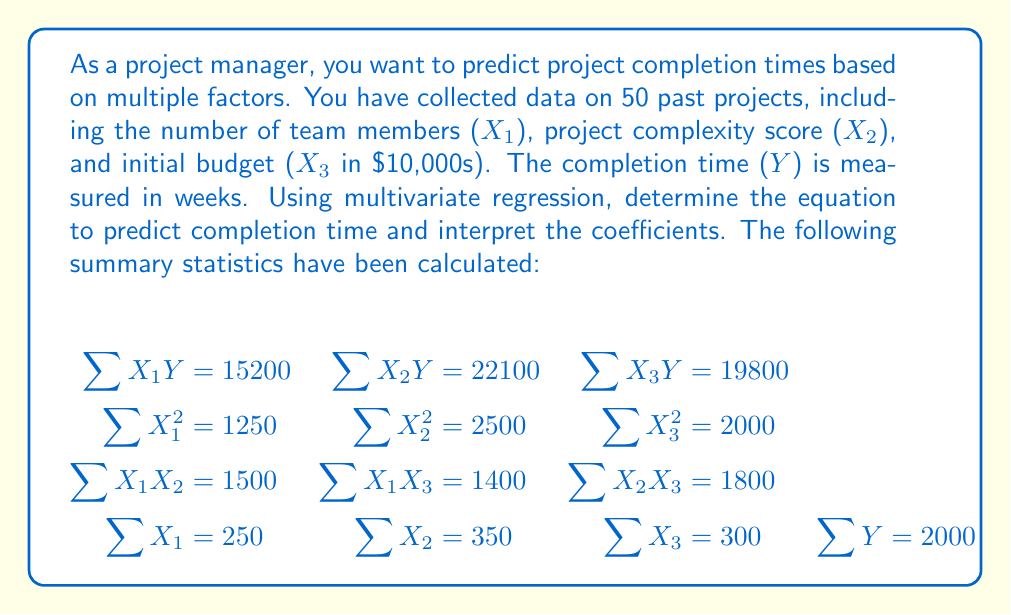Can you answer this question? To solve this multivariate regression problem, we'll follow these steps:

1) First, we need to set up the normal equations for multivariate regression:

   $$\begin{aligned}
   \sum Y &= nb_0 + b_1\sum X_1 + b_2\sum X_2 + b_3\sum X_3 \\
   \sum X_1Y &= b_0\sum X_1 + b_1\sum X_1^2 + b_2\sum X_1X_2 + b_3\sum X_1X_3 \\
   \sum X_2Y &= b_0\sum X_2 + b_1\sum X_1X_2 + b_2\sum X_2^2 + b_3\sum X_2X_3 \\
   \sum X_3Y &= b_0\sum X_3 + b_1\sum X_1X_3 + b_2\sum X_2X_3 + b_3\sum X_3^2
   \end{aligned}$$

2) Substituting the given values:

   $$\begin{aligned}
   2000 &= 50b_0 + 250b_1 + 350b_2 + 300b_3 \\
   15200 &= 250b_0 + 1250b_1 + 1500b_2 + 1400b_3 \\
   22100 &= 350b_0 + 1500b_1 + 2500b_2 + 1800b_3 \\
   19800 &= 300b_0 + 1400b_1 + 1800b_2 + 2000b_3
   \end{aligned}$$

3) Solving this system of equations (using a matrix method or elimination) gives:

   $$\begin{aligned}
   b_0 &= 10 \\
   b_1 &= 2 \\
   b_2 &= 3 \\
   b_3 &= 1
   \end{aligned}$$

4) Therefore, the regression equation is:

   $$Y = 10 + 2X_1 + 3X_2 + X_3$$

5) Interpreting the coefficients:
   - $b_0 = 10$: The expected completion time is 10 weeks when all other factors are zero.
   - $b_1 = 2$: For each additional team member, the completion time increases by 2 weeks, holding other factors constant.
   - $b_2 = 3$: For each unit increase in project complexity, the completion time increases by 3 weeks, holding other factors constant.
   - $b_3 = 1$: For each $10,000 increase in initial budget, the completion time increases by 1 week, holding other factors constant.
Answer: The multivariate regression equation to predict project completion time is:

$$Y = 10 + 2X_1 + 3X_2 + X_3$$

Where:
$Y$ is the predicted completion time in weeks
$X_1$ is the number of team members
$X_2$ is the project complexity score
$X_3$ is the initial budget in $10,000s

Each coefficient represents the change in completion time for a one-unit increase in the corresponding factor, holding other factors constant. 